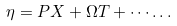<formula> <loc_0><loc_0><loc_500><loc_500>\eta = P X + \Omega T + \cdots \dots</formula> 